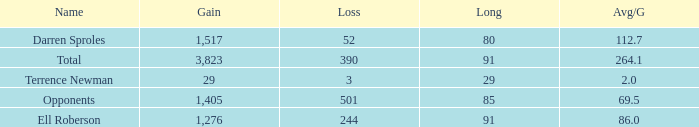Parse the full table. {'header': ['Name', 'Gain', 'Loss', 'Long', 'Avg/G'], 'rows': [['Darren Sproles', '1,517', '52', '80', '112.7'], ['Total', '3,823', '390', '91', '264.1'], ['Terrence Newman', '29', '3', '29', '2.0'], ['Opponents', '1,405', '501', '85', '69.5'], ['Ell Roberson', '1,276', '244', '91', '86.0']]} When the Gain is 29, and the average per game is 2, and the player lost less than 390 yards, what's the sum of the Long yards? None. 